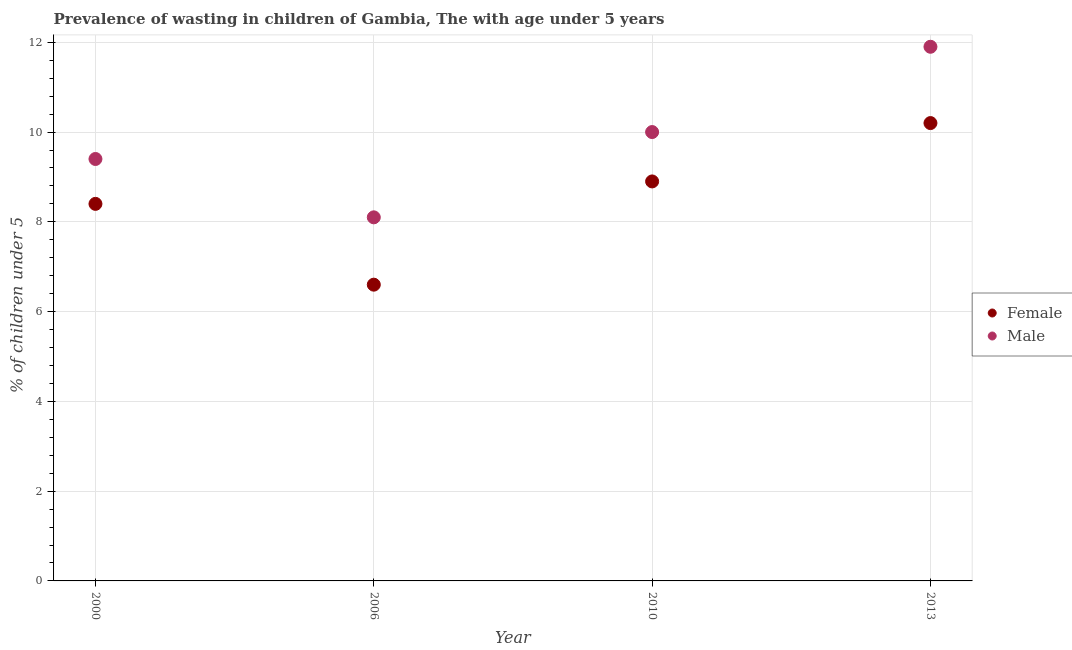How many different coloured dotlines are there?
Your response must be concise. 2. What is the percentage of undernourished female children in 2000?
Give a very brief answer. 8.4. Across all years, what is the maximum percentage of undernourished male children?
Give a very brief answer. 11.9. Across all years, what is the minimum percentage of undernourished male children?
Ensure brevity in your answer.  8.1. What is the total percentage of undernourished male children in the graph?
Offer a very short reply. 39.4. What is the difference between the percentage of undernourished male children in 2010 and that in 2013?
Provide a short and direct response. -1.9. What is the difference between the percentage of undernourished female children in 2006 and the percentage of undernourished male children in 2013?
Your answer should be very brief. -5.3. What is the average percentage of undernourished male children per year?
Provide a succinct answer. 9.85. In the year 2010, what is the difference between the percentage of undernourished male children and percentage of undernourished female children?
Provide a succinct answer. 1.1. What is the ratio of the percentage of undernourished female children in 2006 to that in 2013?
Provide a succinct answer. 0.65. Is the difference between the percentage of undernourished male children in 2006 and 2010 greater than the difference between the percentage of undernourished female children in 2006 and 2010?
Your answer should be very brief. Yes. What is the difference between the highest and the second highest percentage of undernourished male children?
Give a very brief answer. 1.9. What is the difference between the highest and the lowest percentage of undernourished male children?
Your response must be concise. 3.8. In how many years, is the percentage of undernourished male children greater than the average percentage of undernourished male children taken over all years?
Provide a short and direct response. 2. Is the percentage of undernourished male children strictly greater than the percentage of undernourished female children over the years?
Your answer should be compact. Yes. How many dotlines are there?
Your response must be concise. 2. Does the graph contain any zero values?
Ensure brevity in your answer.  No. Does the graph contain grids?
Your response must be concise. Yes. Where does the legend appear in the graph?
Make the answer very short. Center right. How many legend labels are there?
Your answer should be very brief. 2. What is the title of the graph?
Your answer should be compact. Prevalence of wasting in children of Gambia, The with age under 5 years. What is the label or title of the Y-axis?
Make the answer very short.  % of children under 5. What is the  % of children under 5 in Female in 2000?
Your answer should be compact. 8.4. What is the  % of children under 5 in Male in 2000?
Your answer should be very brief. 9.4. What is the  % of children under 5 of Female in 2006?
Give a very brief answer. 6.6. What is the  % of children under 5 of Male in 2006?
Make the answer very short. 8.1. What is the  % of children under 5 in Female in 2010?
Offer a terse response. 8.9. What is the  % of children under 5 of Female in 2013?
Provide a succinct answer. 10.2. What is the  % of children under 5 of Male in 2013?
Provide a short and direct response. 11.9. Across all years, what is the maximum  % of children under 5 of Female?
Your answer should be very brief. 10.2. Across all years, what is the maximum  % of children under 5 in Male?
Ensure brevity in your answer.  11.9. Across all years, what is the minimum  % of children under 5 in Female?
Your response must be concise. 6.6. Across all years, what is the minimum  % of children under 5 in Male?
Ensure brevity in your answer.  8.1. What is the total  % of children under 5 in Female in the graph?
Ensure brevity in your answer.  34.1. What is the total  % of children under 5 of Male in the graph?
Ensure brevity in your answer.  39.4. What is the difference between the  % of children under 5 of Male in 2000 and that in 2006?
Your answer should be very brief. 1.3. What is the difference between the  % of children under 5 of Female in 2000 and that in 2013?
Give a very brief answer. -1.8. What is the difference between the  % of children under 5 of Male in 2006 and that in 2010?
Give a very brief answer. -1.9. What is the difference between the  % of children under 5 of Female in 2006 and that in 2013?
Keep it short and to the point. -3.6. What is the difference between the  % of children under 5 in Female in 2010 and that in 2013?
Make the answer very short. -1.3. What is the difference between the  % of children under 5 in Male in 2010 and that in 2013?
Ensure brevity in your answer.  -1.9. What is the difference between the  % of children under 5 in Female in 2000 and the  % of children under 5 in Male in 2010?
Offer a very short reply. -1.6. What is the difference between the  % of children under 5 in Female in 2000 and the  % of children under 5 in Male in 2013?
Your answer should be compact. -3.5. What is the difference between the  % of children under 5 of Female in 2006 and the  % of children under 5 of Male in 2013?
Provide a short and direct response. -5.3. What is the average  % of children under 5 of Female per year?
Offer a very short reply. 8.53. What is the average  % of children under 5 of Male per year?
Your response must be concise. 9.85. In the year 2000, what is the difference between the  % of children under 5 in Female and  % of children under 5 in Male?
Your answer should be compact. -1. In the year 2010, what is the difference between the  % of children under 5 of Female and  % of children under 5 of Male?
Keep it short and to the point. -1.1. In the year 2013, what is the difference between the  % of children under 5 in Female and  % of children under 5 in Male?
Your response must be concise. -1.7. What is the ratio of the  % of children under 5 of Female in 2000 to that in 2006?
Ensure brevity in your answer.  1.27. What is the ratio of the  % of children under 5 in Male in 2000 to that in 2006?
Give a very brief answer. 1.16. What is the ratio of the  % of children under 5 of Female in 2000 to that in 2010?
Make the answer very short. 0.94. What is the ratio of the  % of children under 5 of Female in 2000 to that in 2013?
Give a very brief answer. 0.82. What is the ratio of the  % of children under 5 in Male in 2000 to that in 2013?
Give a very brief answer. 0.79. What is the ratio of the  % of children under 5 of Female in 2006 to that in 2010?
Your answer should be compact. 0.74. What is the ratio of the  % of children under 5 of Male in 2006 to that in 2010?
Your answer should be compact. 0.81. What is the ratio of the  % of children under 5 of Female in 2006 to that in 2013?
Provide a short and direct response. 0.65. What is the ratio of the  % of children under 5 of Male in 2006 to that in 2013?
Make the answer very short. 0.68. What is the ratio of the  % of children under 5 in Female in 2010 to that in 2013?
Your answer should be very brief. 0.87. What is the ratio of the  % of children under 5 in Male in 2010 to that in 2013?
Your answer should be very brief. 0.84. What is the difference between the highest and the lowest  % of children under 5 in Male?
Ensure brevity in your answer.  3.8. 